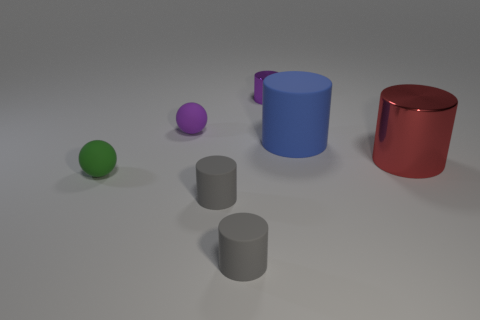Subtract all gray blocks. How many gray cylinders are left? 2 Subtract all large red cylinders. How many cylinders are left? 4 Subtract all purple cylinders. How many cylinders are left? 4 Subtract 2 cylinders. How many cylinders are left? 3 Add 2 red cylinders. How many objects exist? 9 Subtract all yellow cylinders. Subtract all purple spheres. How many cylinders are left? 5 Subtract all spheres. How many objects are left? 5 Subtract all big brown things. Subtract all blue matte things. How many objects are left? 6 Add 5 purple balls. How many purple balls are left? 6 Add 1 large blue cylinders. How many large blue cylinders exist? 2 